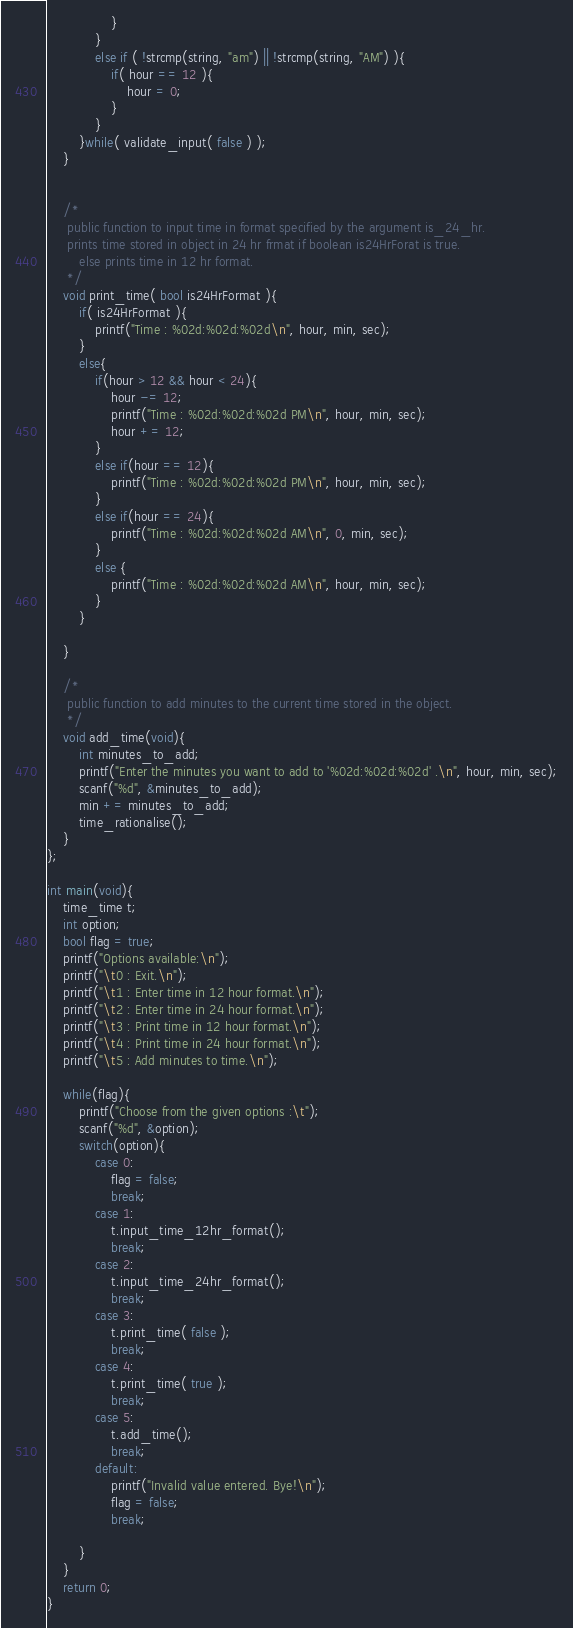<code> <loc_0><loc_0><loc_500><loc_500><_C++_>				}
			}
			else if ( !strcmp(string, "am") || !strcmp(string, "AM") ){
				if( hour == 12 ){
					hour = 0;
				} 
			}
		}while( validate_input( false ) );
	}
	
    
    /*
     public function to input time in format specified by the argument is_24_hr.
     prints time stored in object in 24 hr frmat if boolean is24HrForat is true.
        else prints time in 12 hr format.
     */
	void print_time( bool is24HrFormat ){
		if( is24HrFormat ){
			printf("Time : %02d:%02d:%02d\n", hour, min, sec);
		}
		else{
			if(hour > 12 && hour < 24){
				hour -= 12;
				printf("Time : %02d:%02d:%02d PM\n", hour, min, sec);
				hour += 12;
			}
			else if(hour == 12){
				printf("Time : %02d:%02d:%02d PM\n", hour, min, sec);
			}
			else if(hour == 24){
				printf("Time : %02d:%02d:%02d AM\n", 0, min, sec);
			}
			else {
				printf("Time : %02d:%02d:%02d AM\n", hour, min, sec);
			}
		}
	
	}

    /*
     public function to add minutes to the current time stored in the object.
     */
	void add_time(void){
		int minutes_to_add;
		printf("Enter the minutes you want to add to '%02d:%02d:%02d' .\n", hour, min, sec);
		scanf("%d", &minutes_to_add);
		min += minutes_to_add;
		time_rationalise();
	}
};

int main(void){
	time_time t;
	int option;
	bool flag = true;
	printf("Options available:\n");
	printf("\t0 : Exit.\n");
	printf("\t1 : Enter time in 12 hour format.\n");
	printf("\t2 : Enter time in 24 hour format.\n");
	printf("\t3 : Print time in 12 hour format.\n");
	printf("\t4 : Print time in 24 hour format.\n");
	printf("\t5 : Add minutes to time.\n");

	while(flag){
        printf("Choose from the given options :\t");
        scanf("%d", &option);
		switch(option){
			case 0:
				flag = false;
				break;
			case 1:
				t.input_time_12hr_format();
				break;
			case 2:
				t.input_time_24hr_format();
				break;
			case 3:
				t.print_time( false );
				break;
			case 4:
				t.print_time( true );
				break;
			case 5:
				t.add_time();
				break;
            default:
                printf("Invalid value entered. Bye!\n");
                flag = false;
                break;

		}
	}
	return 0;
}
</code> 